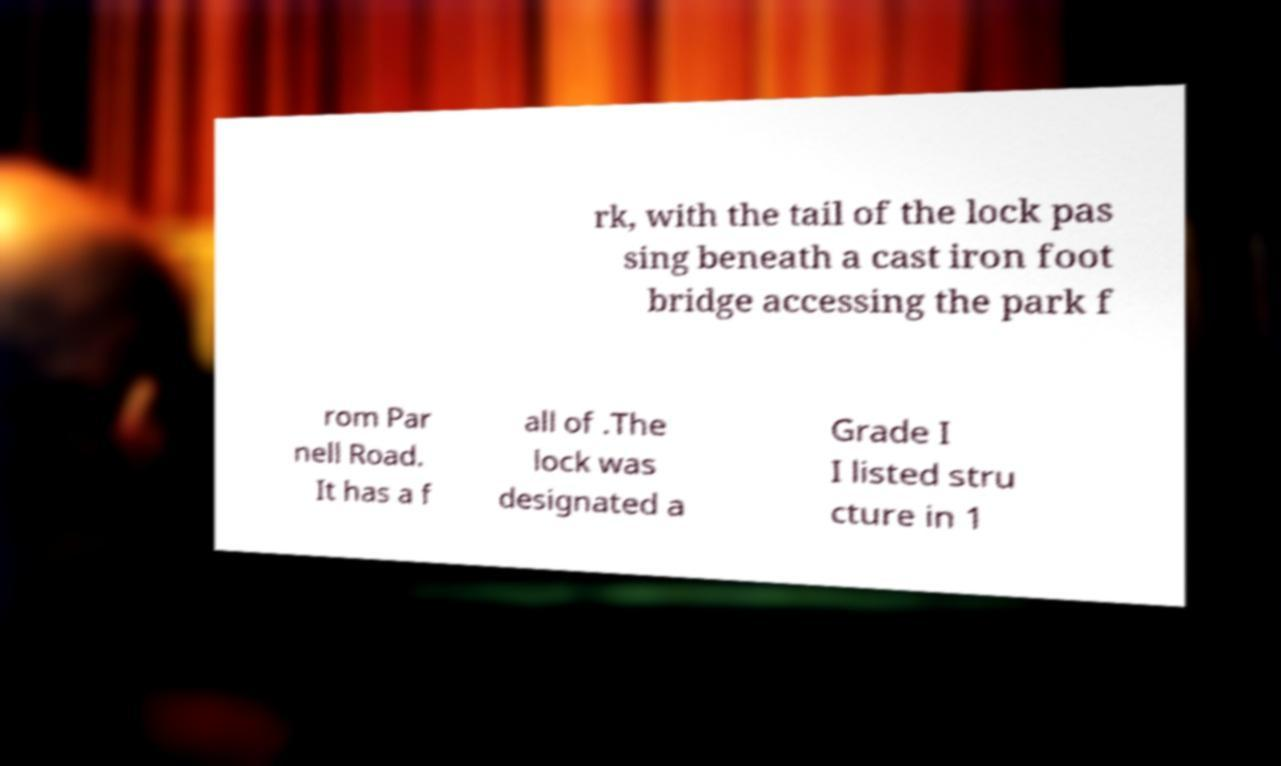What messages or text are displayed in this image? I need them in a readable, typed format. rk, with the tail of the lock pas sing beneath a cast iron foot bridge accessing the park f rom Par nell Road. It has a f all of .The lock was designated a Grade I I listed stru cture in 1 